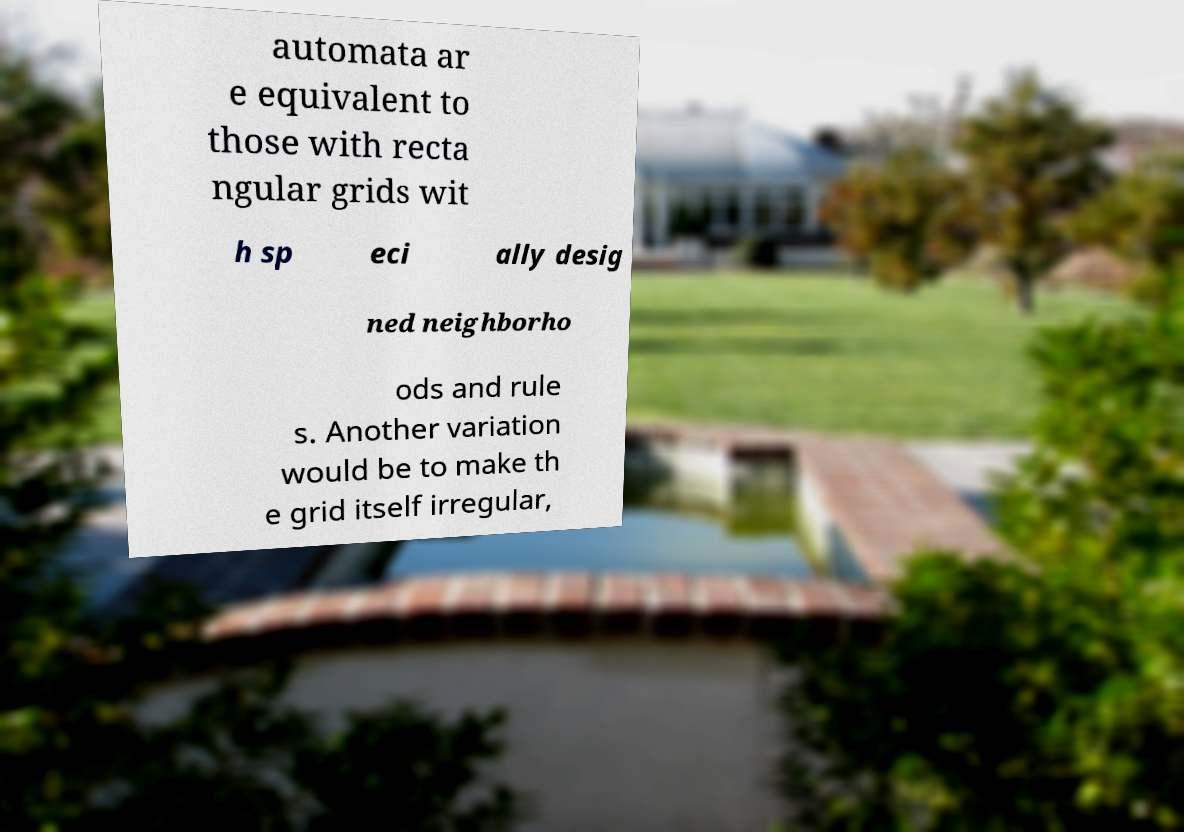What messages or text are displayed in this image? I need them in a readable, typed format. automata ar e equivalent to those with recta ngular grids wit h sp eci ally desig ned neighborho ods and rule s. Another variation would be to make th e grid itself irregular, 